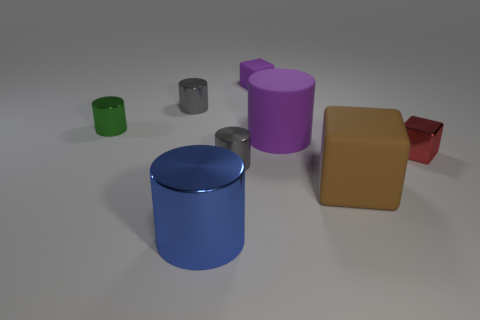Subtract all cyan cylinders. Subtract all yellow cubes. How many cylinders are left? 5 Subtract all yellow cylinders. How many blue cubes are left? 0 Add 7 big blues. How many big things exist? 0 Subtract all large blue metallic cylinders. Subtract all tiny green metal cylinders. How many objects are left? 6 Add 3 tiny green cylinders. How many tiny green cylinders are left? 4 Add 4 metallic cylinders. How many metallic cylinders exist? 8 Add 2 tiny things. How many objects exist? 10 Subtract all purple cubes. How many cubes are left? 2 Subtract all large brown cubes. How many cubes are left? 2 Subtract 1 brown blocks. How many objects are left? 7 